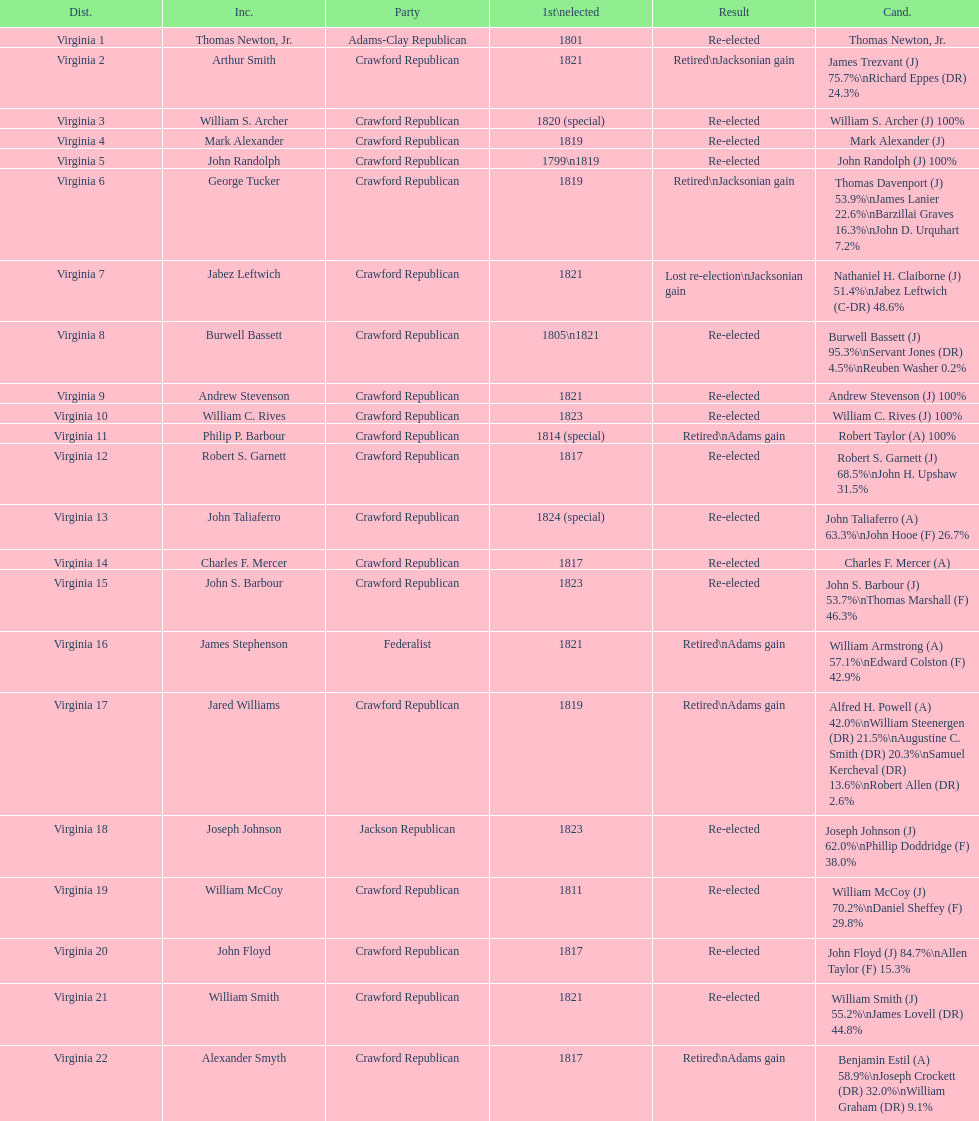What are the number of times re-elected is listed as the result? 15. 